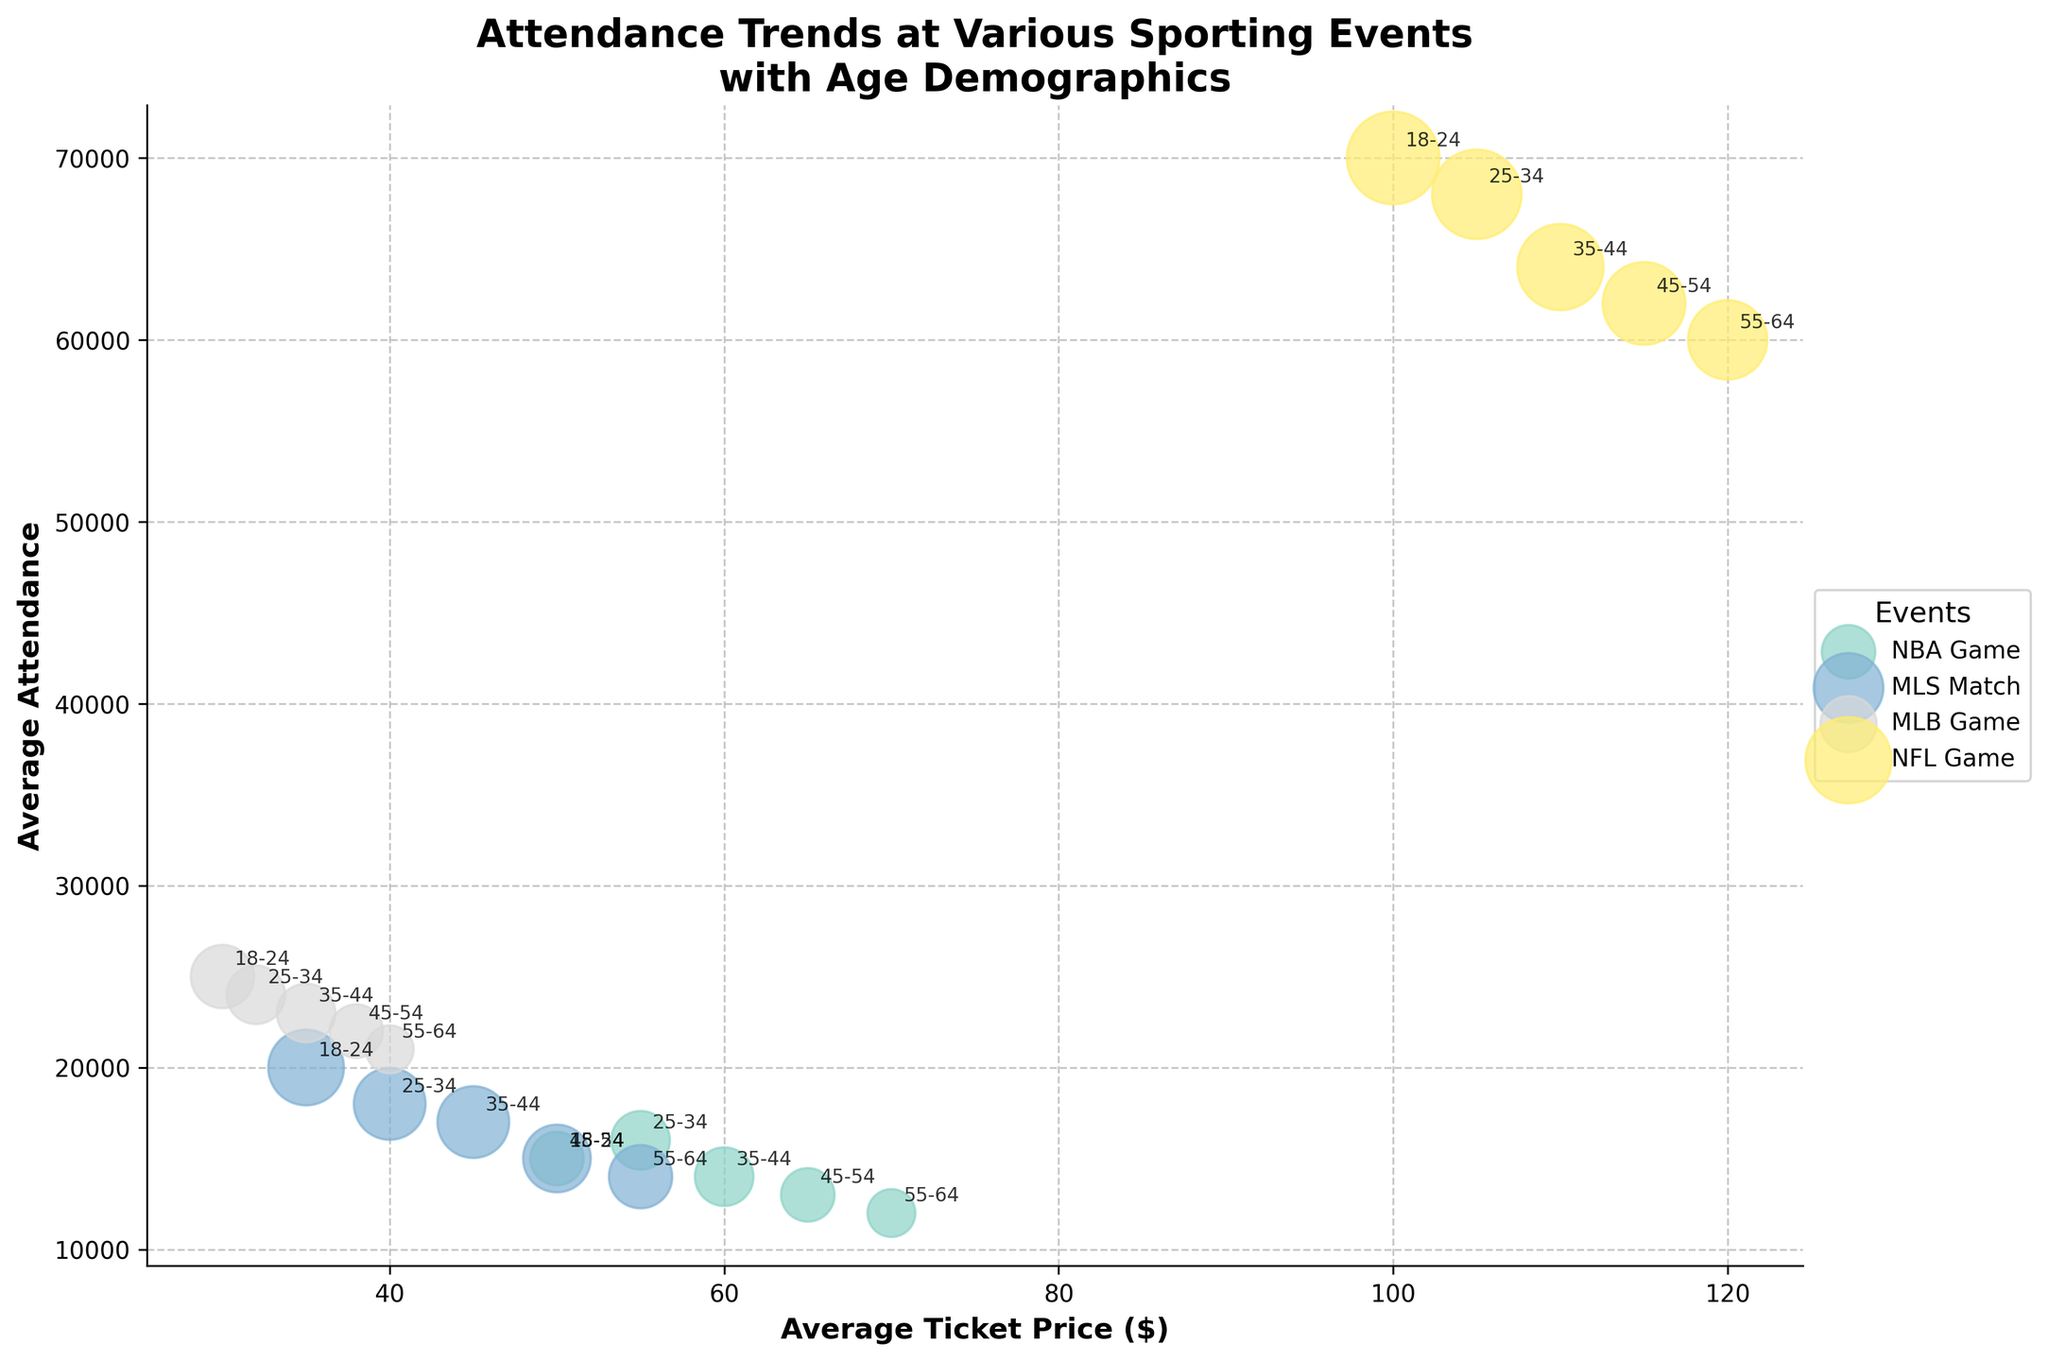What is the title of the figure? The title of the figure is usually located at the top and conveys the main subject of the figure. In this case, the title is "Attendance Trends at Various Sporting Events with Age Demographics".
Answer: Attendance Trends at Various Sporting Events with Age Demographics Which event has the highest average attendance? To answer this, look for the data point with the highest vertical position on the y-axis, which represents average attendance. The NFL Game for the 18-24 age group has the highest bubble at the top-center of the figure.
Answer: NFL Game What is the average ticket price for a 55-64 age group attending an NBA Game? Refer to the bubbles labeled "55-64" within the NBA Game group, and then look horizontally to the x-axis where average ticket prices are indicated. The price is around 70 dollars.
Answer: $70 Which age group has the highest average attendance for MLS Matches? Identify all MLS Match bubbles and find the one highest on the y-axis. The 18-24 age group has the highest average attendance for MLS Matches.
Answer: 18-24 Compare the average ticket prices for the 25-34 age group between MLB Games and NBA Games. Which one is higher? Locate the 25-34 age group bubbles for both MLB Games and NBA Games, then compare their horizontal positions along the x-axis. The NBA Game has a higher average ticket price at $55 compared to the MLB Game at $32.
Answer: NBA Game Which event appears to have the largest bubble size? Bubble size, indicated by visual size on the plot, corresponds to a number in the legend. The NFL Games for all age groups have the largest bubbles, especially for the 18-24 age group.
Answer: NFL Game For which age group does MLS Match see a decline in average attendance? Observe the trend of bubbles associated with each successive age group for MLS Match and see if there is a downward pattern along the y-axis. There is a declining trend from the 18-24 to the 25-34 age group, continuing until 55-64.
Answer: 18-24 to 55-64 How does the average attendance of a 35-44 age group NFL Game compare to an 18-24 age group MLB Game? Find the average attendance for both age groups: 35-44 age group for NFL Game and 18-24 age group for MLB Game. NFL Game has approximately 64,000 attendees, while the MLB Game has 25,000. Compare these two numbers to see that NFL Game attendance is much higher.
Answer: NFL Game has higher average attendance What's the trend in average ticket prices for MLB Games as age increases? Trace the position of the MLB Game bubbles from the younger to older age groups horizontally on the x-axis. The prices gradually increase: $30 (18-24), increasing up to $40 (55-64).
Answer: Increasing What is the difference in average attendance between NBA Game and MLS Match for the 18-24 age group? Locate both NBA Game and MLS Match bubbles for the 18-24 age group on the plot. NBA Game: 15,000 attendees, MLS Match: 20,000 attendees. Compute the difference: 20,000 - 15,000.
Answer: 5,000 